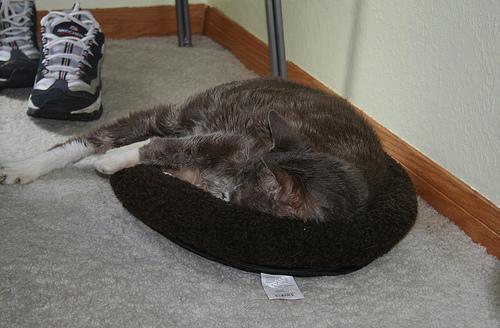How many pairs of shoes are visible in the image?
Give a very brief answer. 1. 